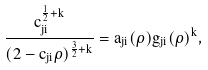<formula> <loc_0><loc_0><loc_500><loc_500>\frac { c _ { j i } ^ { \frac { 1 } { 2 } + k } } { ( 2 - c _ { j i } \rho ) ^ { \frac { 3 } { 2 } + k } } = a _ { j i } ( \rho ) g _ { j i } ( \rho ) ^ { k } ,</formula> 